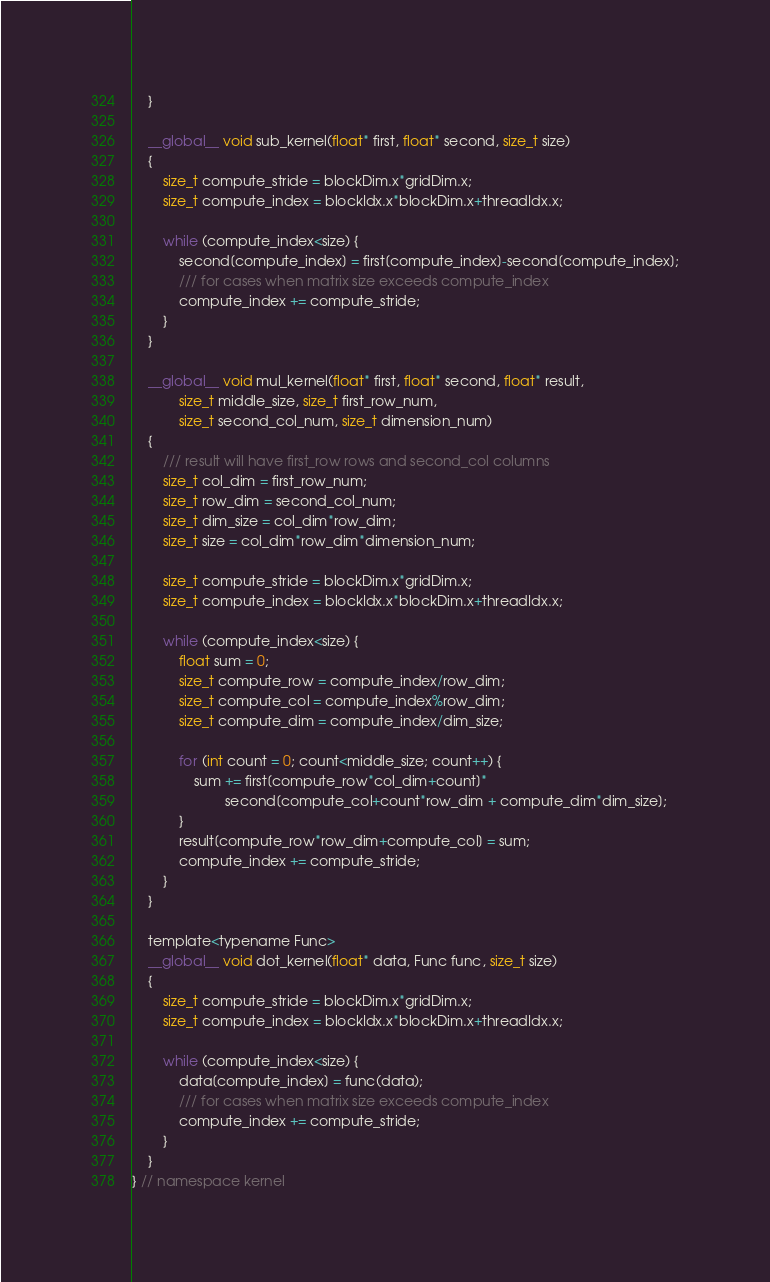<code> <loc_0><loc_0><loc_500><loc_500><_Cuda_>    }

    __global__ void sub_kernel(float* first, float* second, size_t size)
    {
        size_t compute_stride = blockDim.x*gridDim.x;
        size_t compute_index = blockIdx.x*blockDim.x+threadIdx.x;

        while (compute_index<size) {
            second[compute_index] = first[compute_index]-second[compute_index];
            /// for cases when matrix size exceeds compute_index
            compute_index += compute_stride;
        }
    }

    __global__ void mul_kernel(float* first, float* second, float* result,
            size_t middle_size, size_t first_row_num,
            size_t second_col_num, size_t dimension_num)
    {
        /// result will have first_row rows and second_col columns
        size_t col_dim = first_row_num;
        size_t row_dim = second_col_num;
        size_t dim_size = col_dim*row_dim;
        size_t size = col_dim*row_dim*dimension_num;

        size_t compute_stride = blockDim.x*gridDim.x;
        size_t compute_index = blockIdx.x*blockDim.x+threadIdx.x;

        while (compute_index<size) {
            float sum = 0;
            size_t compute_row = compute_index/row_dim;
            size_t compute_col = compute_index%row_dim;
            size_t compute_dim = compute_index/dim_size;

            for (int count = 0; count<middle_size; count++) {
                sum += first[compute_row*col_dim+count]*
                        second[compute_col+count*row_dim + compute_dim*dim_size];
            }
            result[compute_row*row_dim+compute_col] = sum;
            compute_index += compute_stride;
        }
    }

    template<typename Func>
    __global__ void dot_kernel(float* data, Func func, size_t size)
    {
        size_t compute_stride = blockDim.x*gridDim.x;
        size_t compute_index = blockIdx.x*blockDim.x+threadIdx.x;

        while (compute_index<size) {
            data[compute_index] = func(data);
            /// for cases when matrix size exceeds compute_index
            compute_index += compute_stride;
        }
    }
} // namespace kernel
</code> 